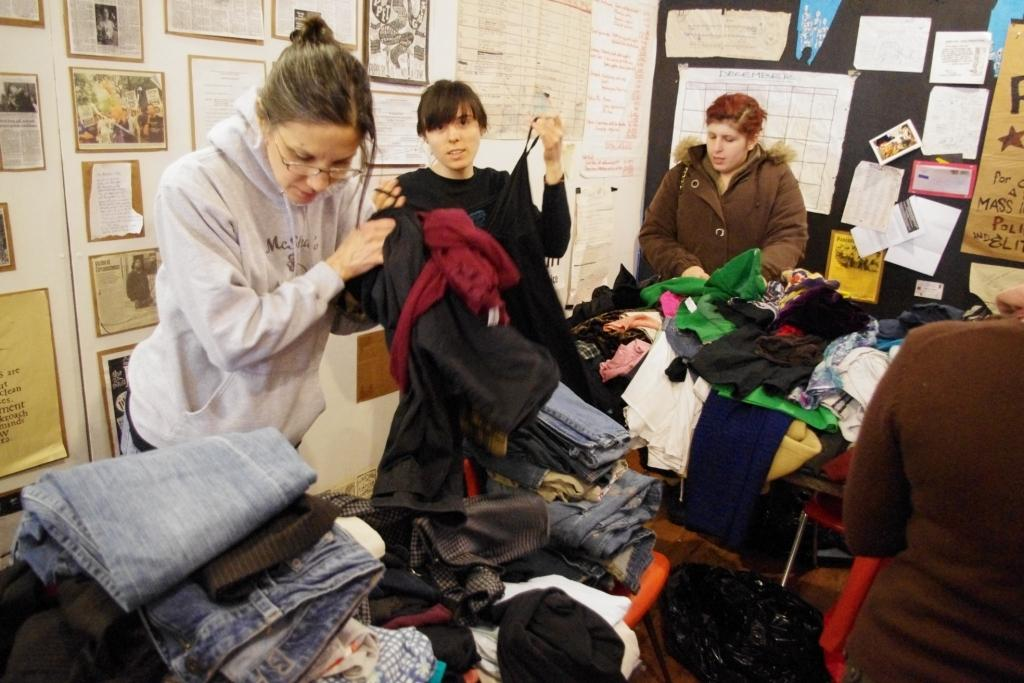What is the main subject of the image? The main subject of the image is a group of people. What is placed in front of the group of people? There are clothes on tables in front of the group of people. What is on the wall behind the group of people? There are papers on the wall behind the group of people. Can you see a jellyfish swimming in the image? No, there is no jellyfish present in the image. 